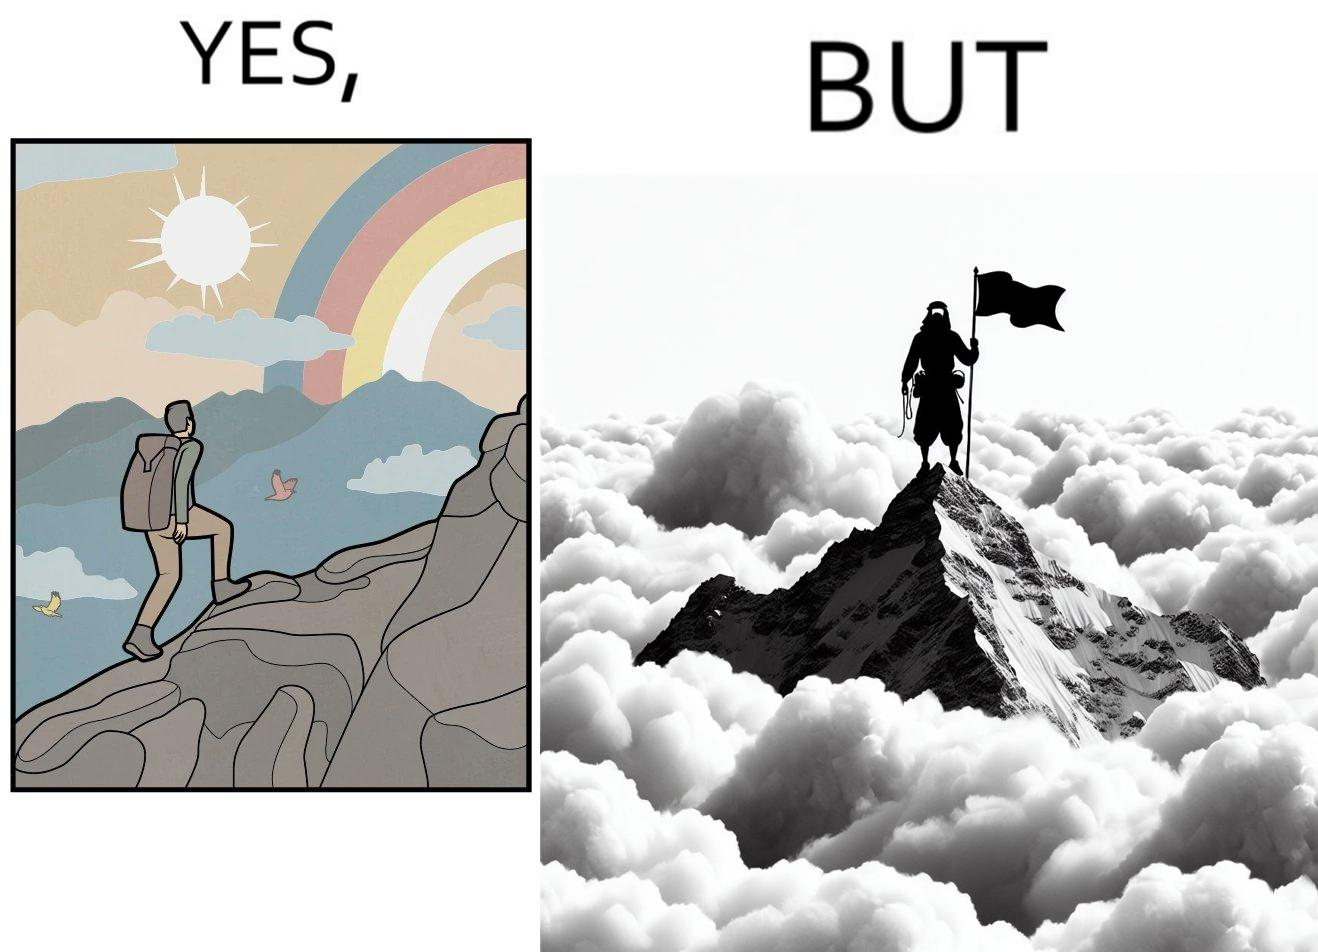Describe the contrast between the left and right parts of this image. In the left part of the image: a mountaineer climbing up the mountain, enjoying the view, birds are flying, rainbow is visible In the right part of the image: a mountaineer is at the peak of the mountain but nothing is visible due to clouds 